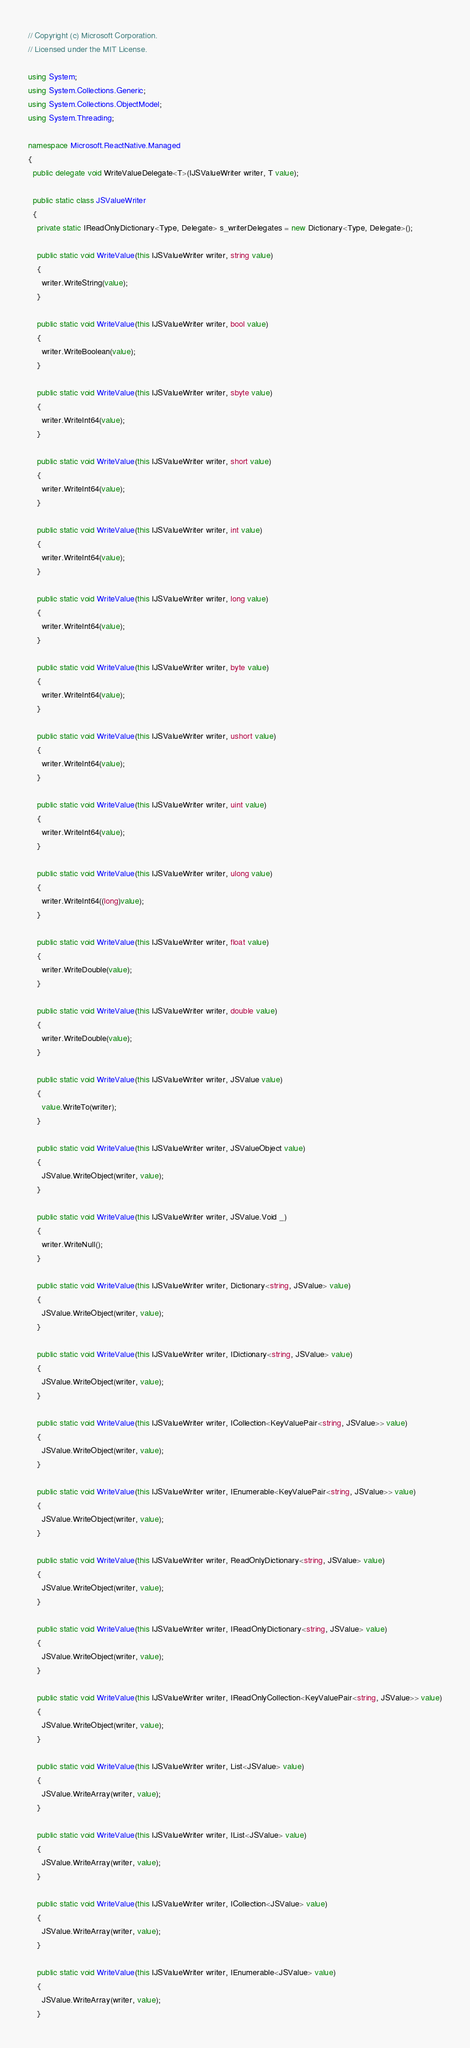<code> <loc_0><loc_0><loc_500><loc_500><_C#_>// Copyright (c) Microsoft Corporation.
// Licensed under the MIT License.

using System;
using System.Collections.Generic;
using System.Collections.ObjectModel;
using System.Threading;

namespace Microsoft.ReactNative.Managed
{
  public delegate void WriteValueDelegate<T>(IJSValueWriter writer, T value);

  public static class JSValueWriter
  {
    private static IReadOnlyDictionary<Type, Delegate> s_writerDelegates = new Dictionary<Type, Delegate>();

    public static void WriteValue(this IJSValueWriter writer, string value)
    {
      writer.WriteString(value);
    }

    public static void WriteValue(this IJSValueWriter writer, bool value)
    {
      writer.WriteBoolean(value);
    }

    public static void WriteValue(this IJSValueWriter writer, sbyte value)
    {
      writer.WriteInt64(value);
    }

    public static void WriteValue(this IJSValueWriter writer, short value)
    {
      writer.WriteInt64(value);
    }

    public static void WriteValue(this IJSValueWriter writer, int value)
    {
      writer.WriteInt64(value);
    }

    public static void WriteValue(this IJSValueWriter writer, long value)
    {
      writer.WriteInt64(value);
    }

    public static void WriteValue(this IJSValueWriter writer, byte value)
    {
      writer.WriteInt64(value);
    }

    public static void WriteValue(this IJSValueWriter writer, ushort value)
    {
      writer.WriteInt64(value);
    }

    public static void WriteValue(this IJSValueWriter writer, uint value)
    {
      writer.WriteInt64(value);
    }

    public static void WriteValue(this IJSValueWriter writer, ulong value)
    {
      writer.WriteInt64((long)value);
    }

    public static void WriteValue(this IJSValueWriter writer, float value)
    {
      writer.WriteDouble(value);
    }

    public static void WriteValue(this IJSValueWriter writer, double value)
    {
      writer.WriteDouble(value);
    }

    public static void WriteValue(this IJSValueWriter writer, JSValue value)
    {
      value.WriteTo(writer);
    }

    public static void WriteValue(this IJSValueWriter writer, JSValueObject value)
    {
      JSValue.WriteObject(writer, value);
    }

    public static void WriteValue(this IJSValueWriter writer, JSValue.Void _)
    {
      writer.WriteNull();
    }

    public static void WriteValue(this IJSValueWriter writer, Dictionary<string, JSValue> value)
    {
      JSValue.WriteObject(writer, value);
    }

    public static void WriteValue(this IJSValueWriter writer, IDictionary<string, JSValue> value)
    {
      JSValue.WriteObject(writer, value);
    }

    public static void WriteValue(this IJSValueWriter writer, ICollection<KeyValuePair<string, JSValue>> value)
    {
      JSValue.WriteObject(writer, value);
    }

    public static void WriteValue(this IJSValueWriter writer, IEnumerable<KeyValuePair<string, JSValue>> value)
    {
      JSValue.WriteObject(writer, value);
    }

    public static void WriteValue(this IJSValueWriter writer, ReadOnlyDictionary<string, JSValue> value)
    {
      JSValue.WriteObject(writer, value);
    }

    public static void WriteValue(this IJSValueWriter writer, IReadOnlyDictionary<string, JSValue> value)
    {
      JSValue.WriteObject(writer, value);
    }

    public static void WriteValue(this IJSValueWriter writer, IReadOnlyCollection<KeyValuePair<string, JSValue>> value)
    {
      JSValue.WriteObject(writer, value);
    }

    public static void WriteValue(this IJSValueWriter writer, List<JSValue> value)
    {
      JSValue.WriteArray(writer, value);
    }

    public static void WriteValue(this IJSValueWriter writer, IList<JSValue> value)
    {
      JSValue.WriteArray(writer, value);
    }

    public static void WriteValue(this IJSValueWriter writer, ICollection<JSValue> value)
    {
      JSValue.WriteArray(writer, value);
    }

    public static void WriteValue(this IJSValueWriter writer, IEnumerable<JSValue> value)
    {
      JSValue.WriteArray(writer, value);
    }
</code> 